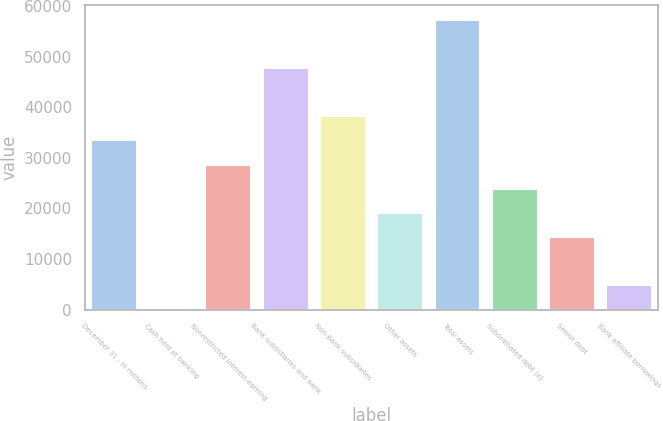Convert chart. <chart><loc_0><loc_0><loc_500><loc_500><bar_chart><fcel>December 31 - in millions<fcel>Cash held at banking<fcel>Nonrestricted interest-earning<fcel>Bank subsidiaries and bank<fcel>Non-bank subsidiaries<fcel>Other assets<fcel>Total assets<fcel>Subordinated debt (a)<fcel>Senior debt<fcel>Bank affiliate borrowings<nl><fcel>33481.3<fcel>1<fcel>28698.4<fcel>47830<fcel>38264.2<fcel>19132.6<fcel>57395.8<fcel>23915.5<fcel>14349.7<fcel>4783.9<nl></chart> 